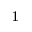Convert formula to latex. <formula><loc_0><loc_0><loc_500><loc_500>^ { 1 }</formula> 